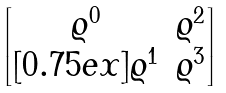<formula> <loc_0><loc_0><loc_500><loc_500>\begin{bmatrix} \varrho ^ { 0 } & \varrho ^ { 2 } \\ [ 0 . 7 5 e x ] \varrho ^ { 1 } & \varrho ^ { 3 } \end{bmatrix}</formula> 